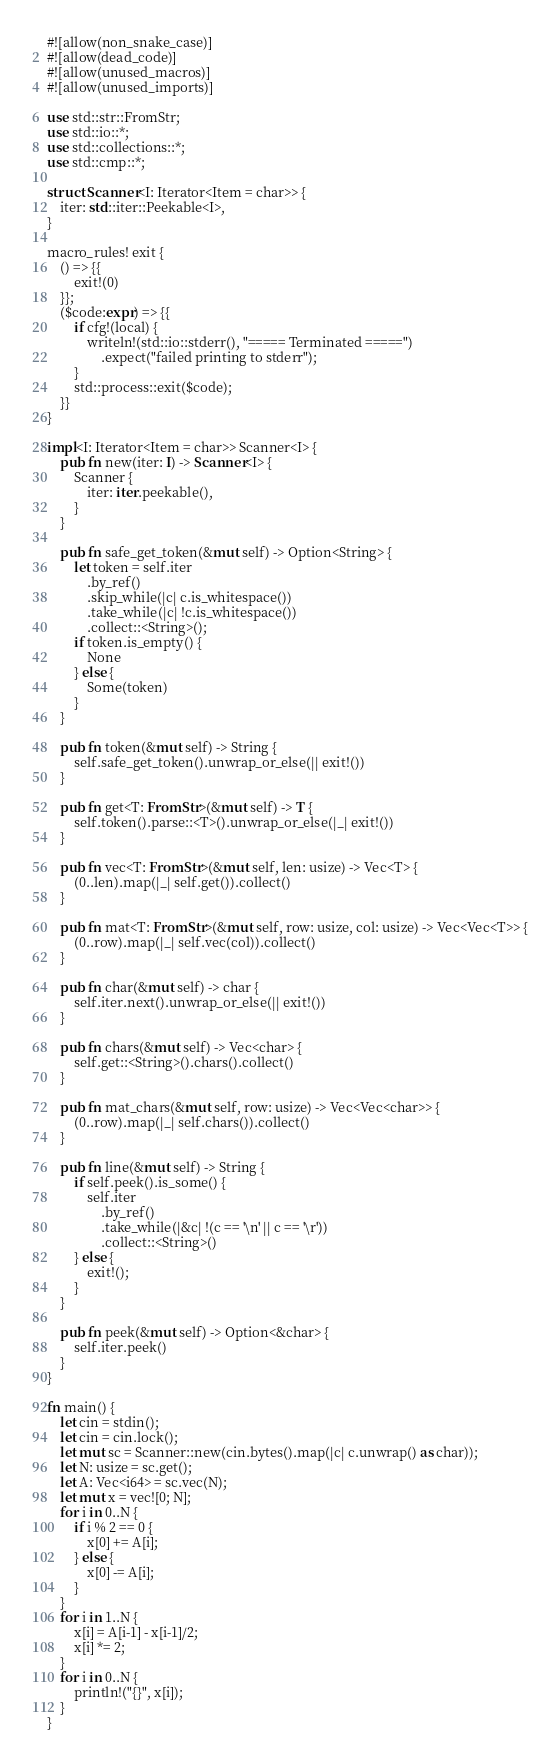Convert code to text. <code><loc_0><loc_0><loc_500><loc_500><_Rust_>#![allow(non_snake_case)]
#![allow(dead_code)]
#![allow(unused_macros)]
#![allow(unused_imports)]

use std::str::FromStr;
use std::io::*;
use std::collections::*;
use std::cmp::*;

struct Scanner<I: Iterator<Item = char>> {
    iter: std::iter::Peekable<I>,
}

macro_rules! exit {
    () => {{
        exit!(0)
    }};
    ($code:expr) => {{
        if cfg!(local) {
            writeln!(std::io::stderr(), "===== Terminated =====")
                .expect("failed printing to stderr");
        }
        std::process::exit($code);
    }}
}

impl<I: Iterator<Item = char>> Scanner<I> {
    pub fn new(iter: I) -> Scanner<I> {
        Scanner {
            iter: iter.peekable(),
        }
    }

    pub fn safe_get_token(&mut self) -> Option<String> {
        let token = self.iter
            .by_ref()
            .skip_while(|c| c.is_whitespace())
            .take_while(|c| !c.is_whitespace())
            .collect::<String>();
        if token.is_empty() {
            None
        } else {
            Some(token)
        }
    }

    pub fn token(&mut self) -> String {
        self.safe_get_token().unwrap_or_else(|| exit!())
    }

    pub fn get<T: FromStr>(&mut self) -> T {
        self.token().parse::<T>().unwrap_or_else(|_| exit!())
    }

    pub fn vec<T: FromStr>(&mut self, len: usize) -> Vec<T> {
        (0..len).map(|_| self.get()).collect()
    }

    pub fn mat<T: FromStr>(&mut self, row: usize, col: usize) -> Vec<Vec<T>> {
        (0..row).map(|_| self.vec(col)).collect()
    }

    pub fn char(&mut self) -> char {
        self.iter.next().unwrap_or_else(|| exit!())
    }

    pub fn chars(&mut self) -> Vec<char> {
        self.get::<String>().chars().collect()
    }

    pub fn mat_chars(&mut self, row: usize) -> Vec<Vec<char>> {
        (0..row).map(|_| self.chars()).collect()
    }

    pub fn line(&mut self) -> String {
        if self.peek().is_some() {
            self.iter
                .by_ref()
                .take_while(|&c| !(c == '\n' || c == '\r'))
                .collect::<String>()
        } else {
            exit!();
        }
    }

    pub fn peek(&mut self) -> Option<&char> {
        self.iter.peek()
    }
}

fn main() {
    let cin = stdin();
    let cin = cin.lock();
    let mut sc = Scanner::new(cin.bytes().map(|c| c.unwrap() as char));
    let N: usize = sc.get();
    let A: Vec<i64> = sc.vec(N);
    let mut x = vec![0; N];
    for i in 0..N {
        if i % 2 == 0 {
            x[0] += A[i];
        } else {
            x[0] -= A[i];
        }
    }
    for i in 1..N {
        x[i] = A[i-1] - x[i-1]/2;
        x[i] *= 2;
    }
    for i in 0..N {
        println!("{}", x[i]);
    }
}
</code> 